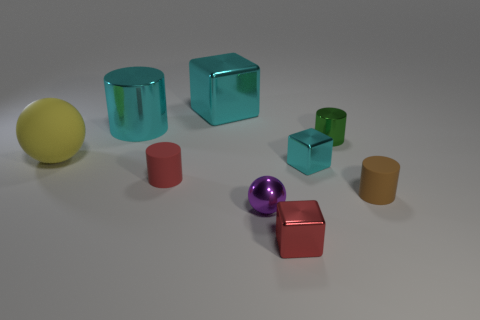Is there a light source within this scene, and if so, where is it coming from? There appears to be a light source in the scene based on the highlights and shadows on the objects. The light seems to be coming from the upper right-hand side of the frame, which is evident from the placement of the shadows and the white highlight seen on the objects, particularly visible on the red shiny cube and the purple sphere. 